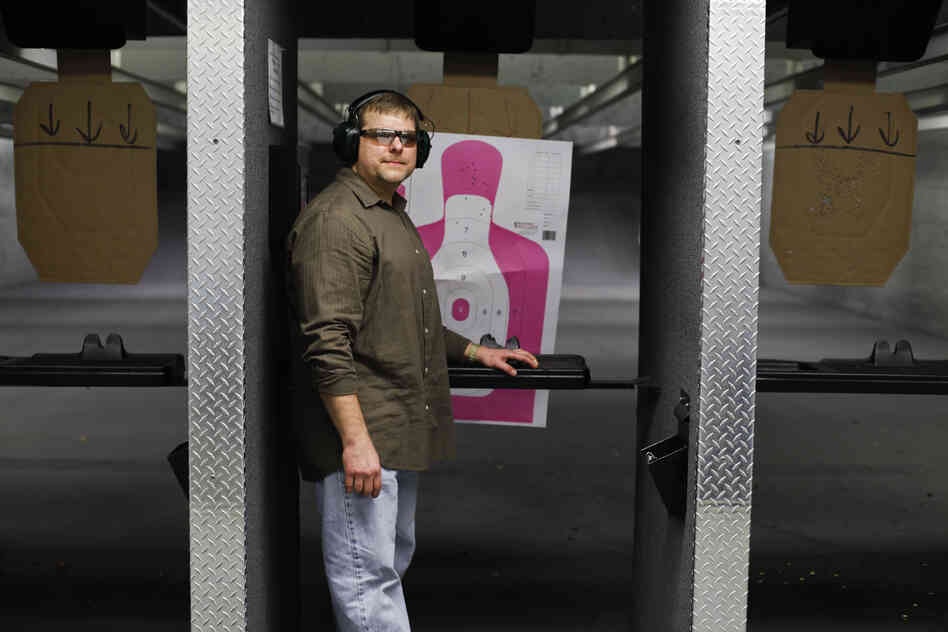Imagine you are designing an entirely new section of this shooting range. What features would you include to enhance user experience? In designing a new section of this shooting range, several features could be included to enhance the user experience. Firstly, incorporating an interactive digital target system would allow for immediate feedback and more dynamic training exercises.

Additionally, providing adjustable booth heights and configurations would cater to shooters of different sizes and preferences, ensuring comfort and accessibility. Including a dedicated area for firearm maintenance and instruction could support users in learning and caring for their equipment.

To promote relaxation and social interaction, a lounge area with comfortable seating and refreshments would be beneficial. Finally, incorporating advanced safety features such as automated lane control and ballistic partitions would further ensure a secure shooting environment. 